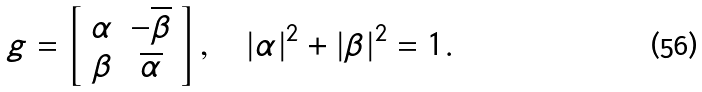Convert formula to latex. <formula><loc_0><loc_0><loc_500><loc_500>g = \left [ \begin{array} { c c } \alpha & - \overline { \beta } \\ \beta & \overline { \alpha } \end{array} \right ] , \quad | \alpha | ^ { 2 } + | \beta | ^ { 2 } = 1 .</formula> 